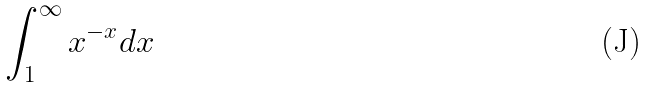<formula> <loc_0><loc_0><loc_500><loc_500>\int _ { 1 } ^ { \infty } x ^ { - x } d x</formula> 